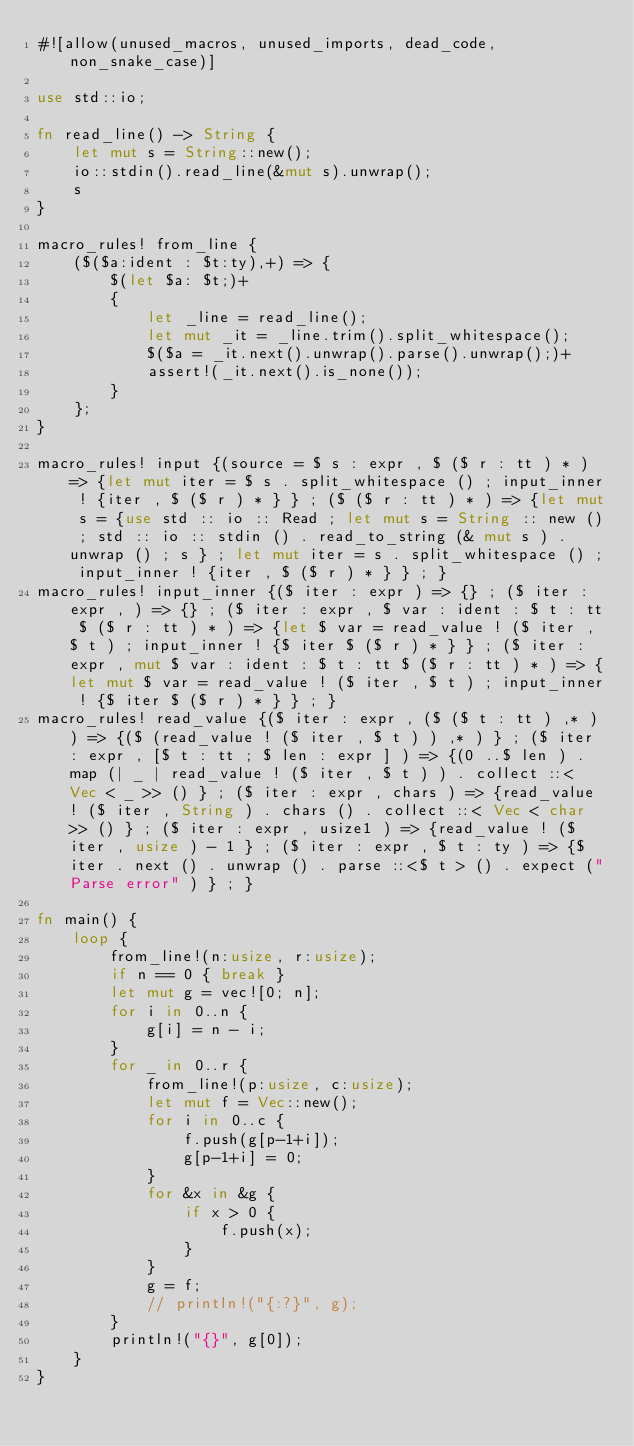<code> <loc_0><loc_0><loc_500><loc_500><_Rust_>#![allow(unused_macros, unused_imports, dead_code, non_snake_case)]

use std::io;

fn read_line() -> String {
    let mut s = String::new();
    io::stdin().read_line(&mut s).unwrap();
    s
}

macro_rules! from_line {
    ($($a:ident : $t:ty),+) => {
        $(let $a: $t;)+
        {
            let _line = read_line();
            let mut _it = _line.trim().split_whitespace();
            $($a = _it.next().unwrap().parse().unwrap();)+
            assert!(_it.next().is_none());
        }
    };
}

macro_rules! input {(source = $ s : expr , $ ($ r : tt ) * ) => {let mut iter = $ s . split_whitespace () ; input_inner ! {iter , $ ($ r ) * } } ; ($ ($ r : tt ) * ) => {let mut s = {use std :: io :: Read ; let mut s = String :: new () ; std :: io :: stdin () . read_to_string (& mut s ) . unwrap () ; s } ; let mut iter = s . split_whitespace () ; input_inner ! {iter , $ ($ r ) * } } ; }
macro_rules! input_inner {($ iter : expr ) => {} ; ($ iter : expr , ) => {} ; ($ iter : expr , $ var : ident : $ t : tt $ ($ r : tt ) * ) => {let $ var = read_value ! ($ iter , $ t ) ; input_inner ! {$ iter $ ($ r ) * } } ; ($ iter : expr , mut $ var : ident : $ t : tt $ ($ r : tt ) * ) => {let mut $ var = read_value ! ($ iter , $ t ) ; input_inner ! {$ iter $ ($ r ) * } } ; }
macro_rules! read_value {($ iter : expr , ($ ($ t : tt ) ,* ) ) => {($ (read_value ! ($ iter , $ t ) ) ,* ) } ; ($ iter : expr , [$ t : tt ; $ len : expr ] ) => {(0 ..$ len ) . map (| _ | read_value ! ($ iter , $ t ) ) . collect ::< Vec < _ >> () } ; ($ iter : expr , chars ) => {read_value ! ($ iter , String ) . chars () . collect ::< Vec < char >> () } ; ($ iter : expr , usize1 ) => {read_value ! ($ iter , usize ) - 1 } ; ($ iter : expr , $ t : ty ) => {$ iter . next () . unwrap () . parse ::<$ t > () . expect ("Parse error" ) } ; }

fn main() {
    loop {
        from_line!(n:usize, r:usize);
        if n == 0 { break }
        let mut g = vec![0; n];
        for i in 0..n {
            g[i] = n - i;
        }
        for _ in 0..r {
            from_line!(p:usize, c:usize);
            let mut f = Vec::new();
            for i in 0..c {
                f.push(g[p-1+i]);
                g[p-1+i] = 0;
            }
            for &x in &g {
                if x > 0 {
                    f.push(x);
                }
            }
            g = f;
            // println!("{:?}", g);
        }
        println!("{}", g[0]);
    }
}

</code> 